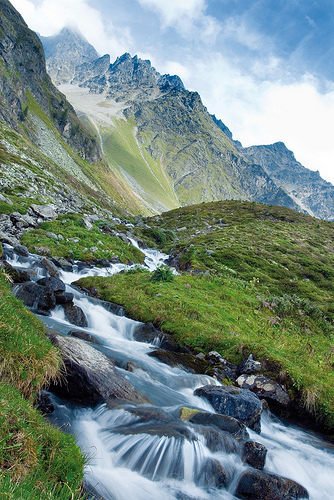<image>
Can you confirm if the river is on the hill? Yes. Looking at the image, I can see the river is positioned on top of the hill, with the hill providing support. 